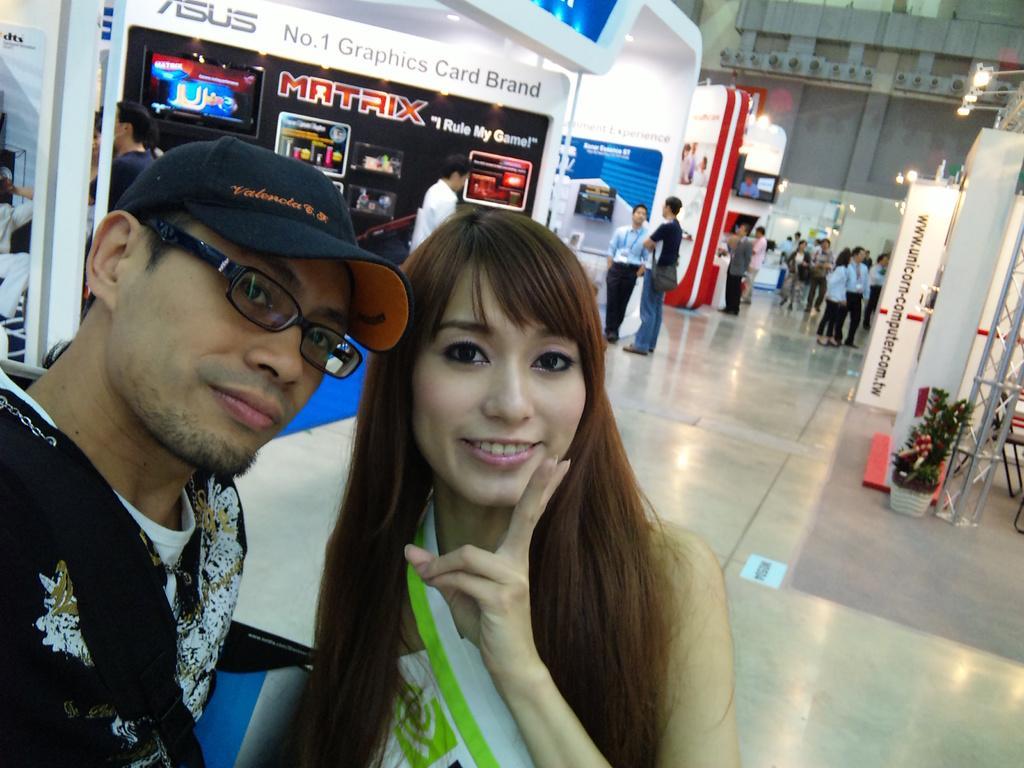Can you describe this image briefly? In the foreground I can see there are two persons and they both are smiling and back side of them I can see shops , in front of the shop I can see persons and on the right side I can see a flower pot and stand and I can see the lights. 